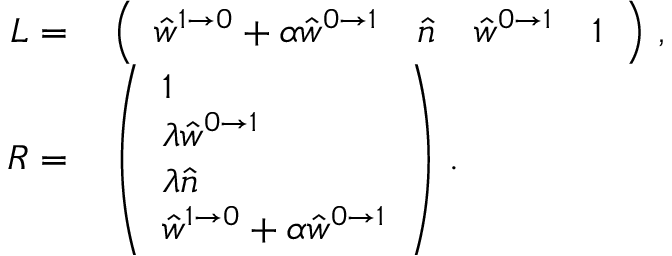Convert formula to latex. <formula><loc_0><loc_0><loc_500><loc_500>\begin{array} { r l } { L = } & \left ( \begin{array} { l l l l } { \hat { w } ^ { 1 \to 0 } + \alpha \hat { w } ^ { 0 \to 1 } } & { \hat { n } } & { \hat { w } ^ { 0 \to 1 } } & { \mathbb { 1 } } \end{array} \right ) \, , } \\ { R = } & \left ( \begin{array} { l } { \mathbb { 1 } } \\ { \lambda \hat { w } ^ { 0 \to 1 } } \\ { \lambda \hat { n } } \\ { \hat { w } ^ { 1 \to 0 } + \alpha \hat { w } ^ { 0 \to 1 } } \end{array} \right ) \, . } \end{array}</formula> 